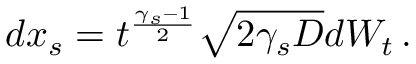Convert formula to latex. <formula><loc_0><loc_0><loc_500><loc_500>d x _ { s } = t ^ { \frac { \gamma _ { s } - 1 } { 2 } } \sqrt { 2 \gamma _ { s } D } d W _ { t } \, .</formula> 